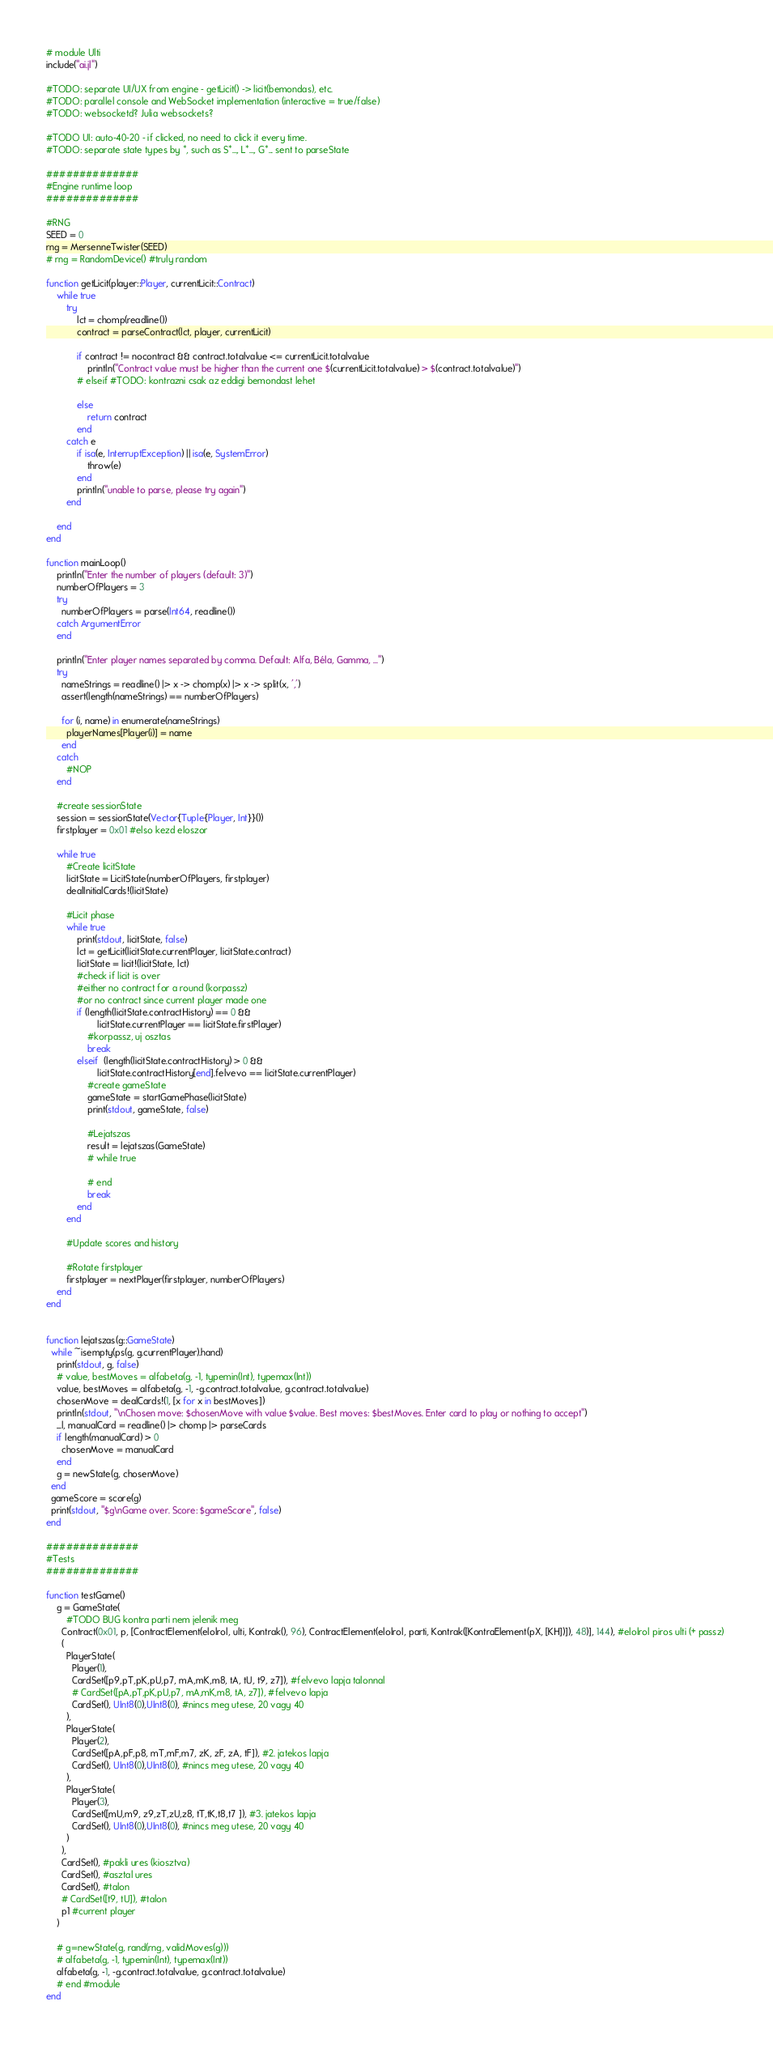<code> <loc_0><loc_0><loc_500><loc_500><_Julia_>
# module Ulti
include("ai.jl")

#TODO: separate UI/UX from engine - getLicit() -> licit(bemondas), etc.
#TODO: parallel console and WebSocket implementation (interactive = true/false)
#TODO: websocketd? Julia websockets?

#TODO UI: auto-40-20 - if clicked, no need to click it every time.
#TODO: separate state types by *, such as S*..., L*..., G*... sent to parseState

##############
#Engine runtime loop
##############

#RNG
SEED = 0
rng = MersenneTwister(SEED)
# rng = RandomDevice() #truly random

function getLicit(player::Player, currentLicit::Contract)
    while true
        try
            lct = chomp(readline())
            contract = parseContract(lct, player, currentLicit)

            if contract != nocontract && contract.totalvalue <= currentLicit.totalvalue
                println("Contract value must be higher than the current one $(currentLicit.totalvalue) > $(contract.totalvalue)")
            # elseif #TODO: kontrazni csak az eddigi bemondast lehet

            else
                return contract
            end
        catch e
            if isa(e, InterruptException) || isa(e, SystemError)
                throw(e)
            end
            println("unable to parse, please try again")
        end

    end
end

function mainLoop()
    println("Enter the number of players (default: 3)")
    numberOfPlayers = 3
    try
      numberOfPlayers = parse(Int64, readline())
    catch ArgumentError
    end

    println("Enter player names separated by comma. Default: Alfa, Béla, Gamma, ...")
    try
      nameStrings = readline() |> x -> chomp(x) |> x -> split(x, ',')
      assert(length(nameStrings) == numberOfPlayers)

      for (i, name) in enumerate(nameStrings)
        playerNames[Player(i)] = name
      end
    catch
        #NOP
    end

    #create sessionState
    session = sessionState(Vector{Tuple{Player, Int}}())
    firstplayer = 0x01 #elso kezd eloszor

    while true
        #Create licitState
        licitState = LicitState(numberOfPlayers, firstplayer)
        dealInitialCards!(licitState)

        #Licit phase
        while true
            print(stdout, licitState, false)
            lct = getLicit(licitState.currentPlayer, licitState.contract)
            licitState = licit!(licitState, lct)
            #check if licit is over
            #either no contract for a round (korpassz)
            #or no contract since current player made one
            if (length(licitState.contractHistory) == 0 &&
                    licitState.currentPlayer == licitState.firstPlayer)
                #korpassz, uj osztas
                break
            elseif  (length(licitState.contractHistory) > 0 && 
                    licitState.contractHistory[end].felvevo == licitState.currentPlayer)    
                #create gameState
                gameState = startGamePhase(licitState)
                print(stdout, gameState, false)

                #Lejatszas
                result = lejatszas(GameState)
                # while true

                # end
                break
            end
        end

        #Update scores and history

        #Rotate firstplayer
        firstplayer = nextPlayer(firstplayer, numberOfPlayers)
    end
end


function lejatszas(g::GameState)
  while ~isempty(ps(g, g.currentPlayer).hand)
    print(stdout, g, false)
    # value, bestMoves = alfabeta(g, -1, typemin(Int), typemax(Int))
    value, bestMoves = alfabeta(g, -1, -g.contract.totalvalue, g.contract.totalvalue)
    chosenMove = dealCards!(1, [x for x in bestMoves])
    println(stdout, "\nChosen move: $chosenMove with value $value. Best moves: $bestMoves. Enter card to play or nothing to accept")
    _l, manualCard = readline() |> chomp |> parseCards
    if length(manualCard) > 0
      chosenMove = manualCard
    end
    g = newState(g, chosenMove)
  end
  gameScore = score(g)
  print(stdout, "$g\nGame over. Score: $gameScore", false)
end

##############
#Tests
##############

function testGame()
    g = GameState(
        #TODO BUG kontra parti nem jelenik meg
      Contract(0x01, p, [ContractElement(elolrol, ulti, Kontrak(), 96), ContractElement(elolrol, parti, Kontrak([KontraElement(pX, [KH])]), 48)], 144), #elolrol piros ulti (+ passz) 
      (
        PlayerState(
          Player(1),
          CardSet([p9,pT,pK,pU,p7, mA,mK,m8, tA, tU, t9, z7]), #felvevo lapja talonnal
          # CardSet([pA,pT,pK,pU,p7, mA,mK,m8, tA, z7]), #felvevo lapja
          CardSet(), UInt8(0),UInt8(0), #nincs meg utese, 20 vagy 40
        ),
        PlayerState(
          Player(2),
          CardSet([pA,pF,p8, mT,mF,m7, zK, zF, zA, tF]), #2. jatekos lapja
          CardSet(), UInt8(0),UInt8(0), #nincs meg utese, 20 vagy 40
        ),
        PlayerState(
          Player(3),
          CardSet([mU,m9, z9,zT,zU,z8, tT,tK,t8,t7 ]), #3. jatekos lapja
          CardSet(), UInt8(0),UInt8(0), #nincs meg utese, 20 vagy 40
        )
      ),
      CardSet(), #pakli ures (kiosztva)
      CardSet(), #asztal ures
      CardSet(), #talon
      # CardSet([t9, tU]), #talon
      p1 #current player
    )

    # g=newState(g, rand(rng, validMoves(g)))
    # alfabeta(g, -1, typemin(Int), typemax(Int))
    alfabeta(g, -1, -g.contract.totalvalue, g.contract.totalvalue)
    # end #module
end
</code> 